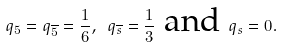Convert formula to latex. <formula><loc_0><loc_0><loc_500><loc_500>q _ { 5 } = q _ { \overline { 5 } } = \frac { 1 } { 6 } , \text { } q _ { \overline { s } } = \frac { 1 } { 3 } \text { and } q _ { s } = 0 .</formula> 